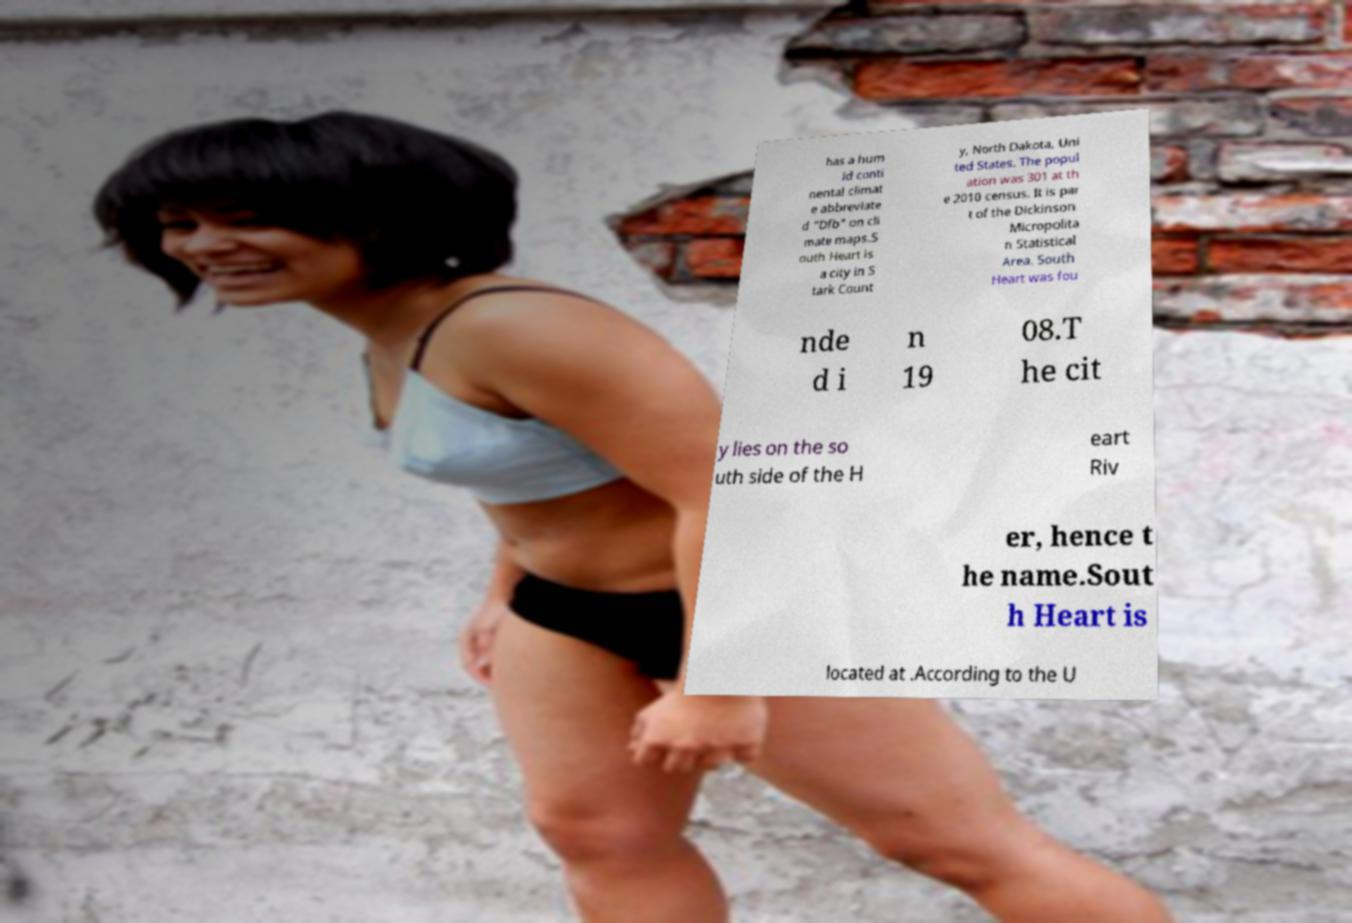Could you assist in decoding the text presented in this image and type it out clearly? has a hum id conti nental climat e abbreviate d "Dfb" on cli mate maps.S outh Heart is a city in S tark Count y, North Dakota, Uni ted States. The popul ation was 301 at th e 2010 census. It is par t of the Dickinson Micropolita n Statistical Area. South Heart was fou nde d i n 19 08.T he cit y lies on the so uth side of the H eart Riv er, hence t he name.Sout h Heart is located at .According to the U 